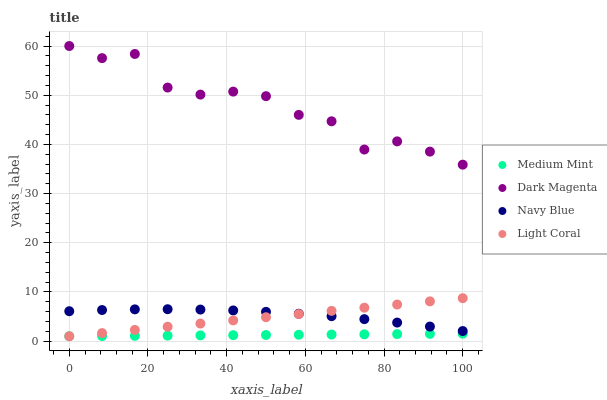Does Medium Mint have the minimum area under the curve?
Answer yes or no. Yes. Does Dark Magenta have the maximum area under the curve?
Answer yes or no. Yes. Does Navy Blue have the minimum area under the curve?
Answer yes or no. No. Does Navy Blue have the maximum area under the curve?
Answer yes or no. No. Is Medium Mint the smoothest?
Answer yes or no. Yes. Is Dark Magenta the roughest?
Answer yes or no. Yes. Is Navy Blue the smoothest?
Answer yes or no. No. Is Navy Blue the roughest?
Answer yes or no. No. Does Medium Mint have the lowest value?
Answer yes or no. Yes. Does Navy Blue have the lowest value?
Answer yes or no. No. Does Dark Magenta have the highest value?
Answer yes or no. Yes. Does Navy Blue have the highest value?
Answer yes or no. No. Is Navy Blue less than Dark Magenta?
Answer yes or no. Yes. Is Dark Magenta greater than Light Coral?
Answer yes or no. Yes. Does Medium Mint intersect Light Coral?
Answer yes or no. Yes. Is Medium Mint less than Light Coral?
Answer yes or no. No. Is Medium Mint greater than Light Coral?
Answer yes or no. No. Does Navy Blue intersect Dark Magenta?
Answer yes or no. No. 